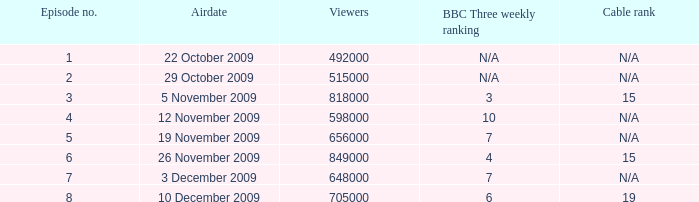Where where the bbc three weekly ranking for episode no. 5? 7.0. 